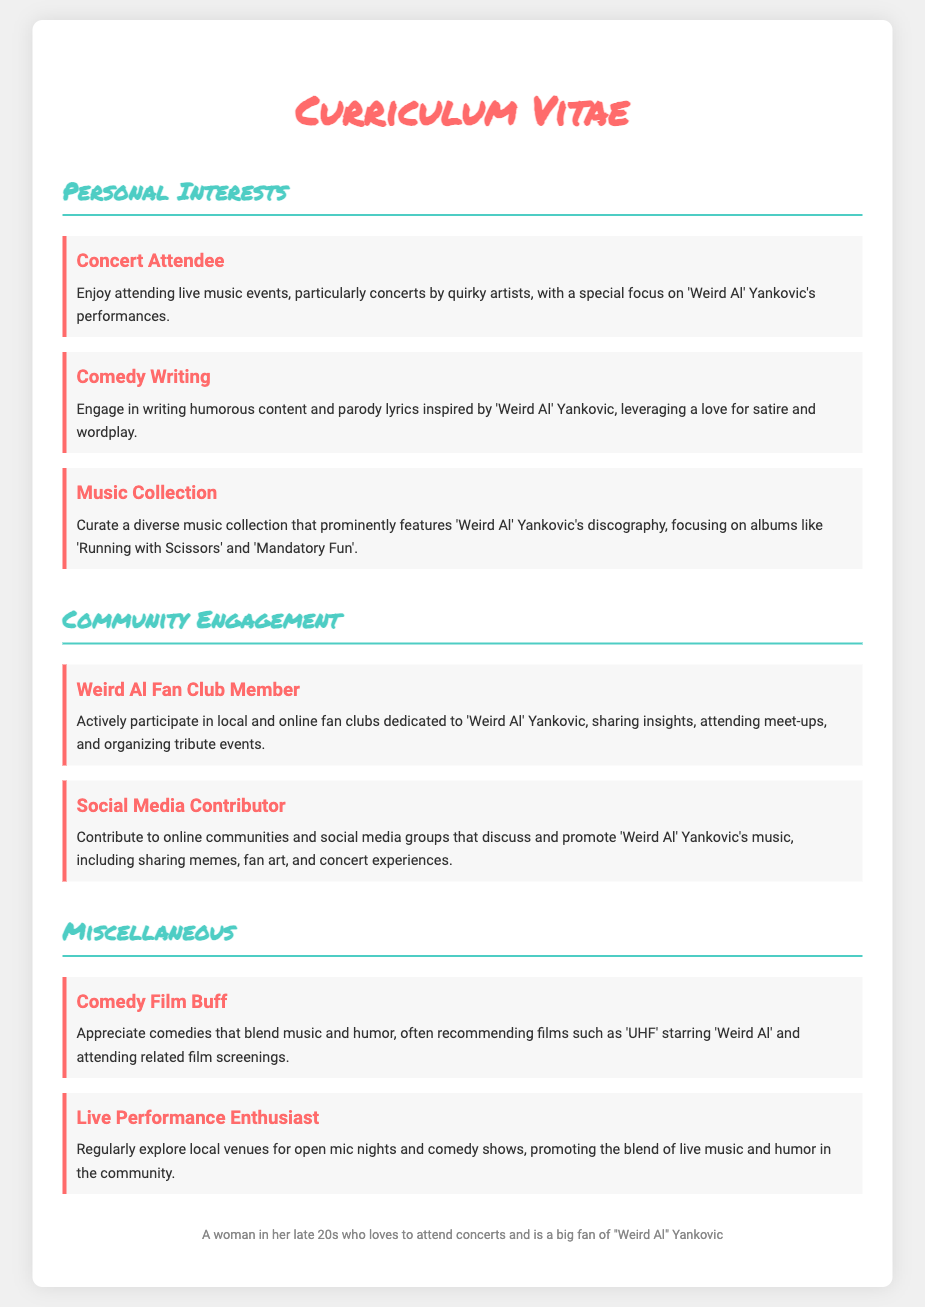What is the overall theme of the personal interests section? The personal interests section primarily focuses on music, comedy, and community engagement surrounding 'Weird Al' Yankovic.
Answer: Music, comedy, community engagement How many hobbies are listed under personal interests? There are six hobbies mentioned in the personal interests section.
Answer: Six What is the title of the first hobby mentioned? The first hobby listed is "Concert Attendee."
Answer: Concert Attendee Which album is specifically mentioned in the Music Collection hobby? The album "Mandatory Fun" is highlighted in the Music Collection section.
Answer: Mandatory Fun What type of community does the individual participate in regarding 'Weird Al' Yankovic? The individual participates in local and online fan clubs dedicated to 'Weird Al' Yankovic.
Answer: Fan clubs What comedic film starring 'Weird Al' is mentioned? The film mentioned is "UHF."
Answer: UHF In which hobby does the individual engage in writing humorous content? The hobby related to writing humorous content is titled "Comedy Writing."
Answer: Comedy Writing What type of events does the individual regularly explore? The individual explores local open mic nights and comedy shows.
Answer: Open mic nights and comedy shows 